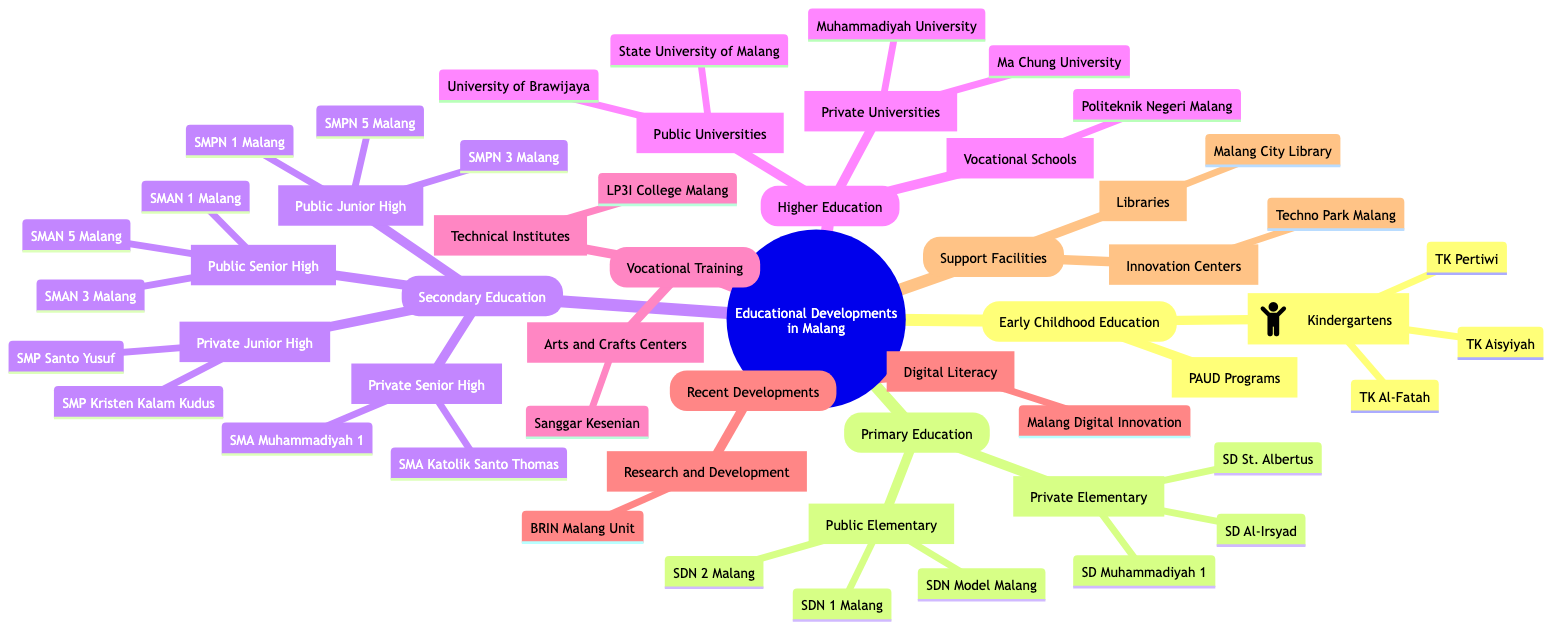What are the names of three private elementary schools in Malang? The diagram lists three private elementary schools under the "Private Elementary Schools" node: SD Muhammadiyah 1, SD Al-Irsyad, and SD St. Albertus.
Answer: SD Muhammadiyah 1, SD Al-Irsyad, SD St. Albertus How many public junior high schools are mentioned in the diagram? Under the "Public Junior High" section, there are three listed schools: SMPN 1 Malang, SMPN 3 Malang, and SMPN 5 Malang. Therefore, the total is three.
Answer: 3 What type of institutions are located under "Higher Education"? The "Higher Education" node includes "Public Universities," "Private Universities," and "Vocational Schools." This categorizes the institutions under these specific types.
Answer: Public Universities, Private Universities, Vocational Schools Which vocational training institute focuses on arts and crafts in Malang? The diagram indicates "Sanggar Kesenian Dharmo Gandhul" as the arts and crafts center under the "Arts and Crafts Centers" section of "Vocational Training."
Answer: Sanggar Kesenian Dharmo Gandhul What is a recent development program related to digital literacy in Malang? The diagram notes "Malang Digital Innovation Lounge" as a digital literacy program under the "Digital Literacy Programs" section in "Recent Developments."
Answer: Malang Digital Innovation Lounge How many schools are classified as private senior high schools? Under the "Private Senior High" section, there are three schools listed: SMA Katolik Santo Thomas, SMA Muhammadiyah 1, and SMA Laboratorium UM, totaling three private senior high schools.
Answer: 3 What function do the "Innovation Centers" serve? The "Innovation Centers" node, which includes "Techno Park Malang" and "Malang Creative Fusion," indicates that they are support facilities aimed at fostering innovation in the region.
Answer: Support facilities for innovation What programs are included under Early Childhood Education in Malang? The diagram shows "Kindergartens" and "PAUD Programs" listed under the "Early Childhood Education" node, indicating various education options available for young children.
Answer: Kindergartens, PAUD Programs 